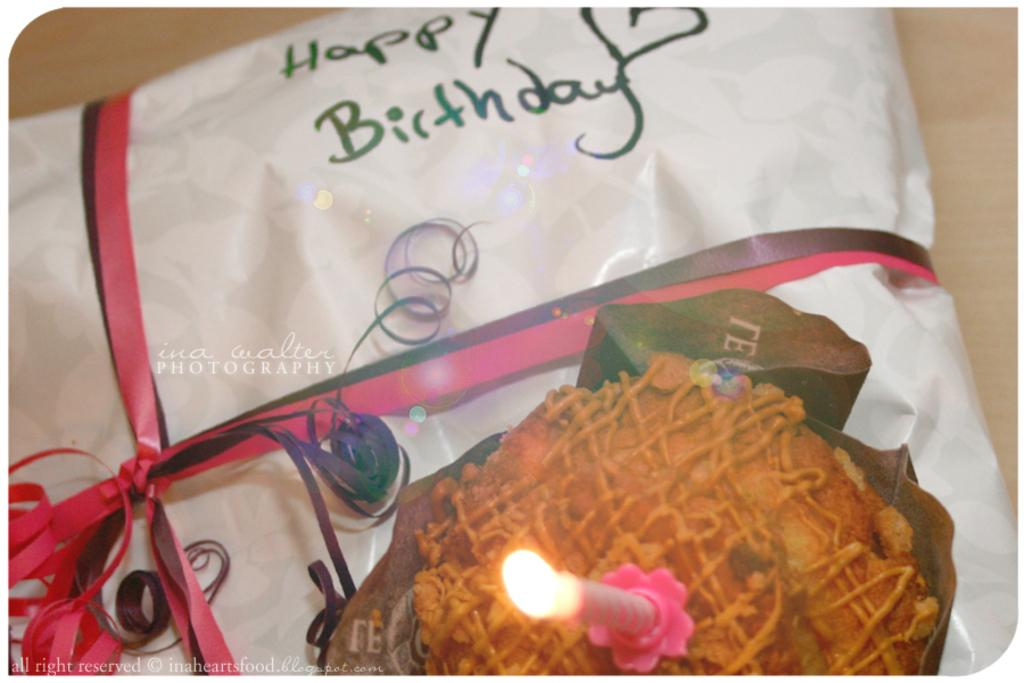What object in the image is associated with a celebration? There is a gift in the image, which is associated with a celebration. What message is written on the gift? The gift has the text 'happy birthday' on it. What other celebratory item can be seen in the image? There is a cake in the image. What decoration is on the cake? There is a candle on the cake. What type of winter clothing is hanging on the wall in the image? There is no winter clothing or wall present in the image; it features a gift, a cake, and a candle. 